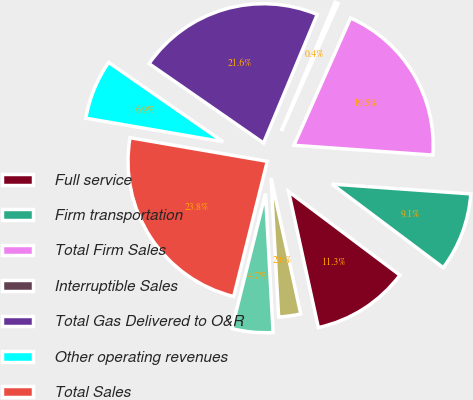Convert chart. <chart><loc_0><loc_0><loc_500><loc_500><pie_chart><fcel>Full service<fcel>Firm transportation<fcel>Total Firm Sales<fcel>Interruptible Sales<fcel>Total Gas Delivered to O&R<fcel>Other operating revenues<fcel>Total Sales<fcel>Residential<fcel>General<nl><fcel>11.32%<fcel>9.13%<fcel>19.46%<fcel>0.37%<fcel>21.65%<fcel>6.94%<fcel>23.84%<fcel>4.75%<fcel>2.56%<nl></chart> 